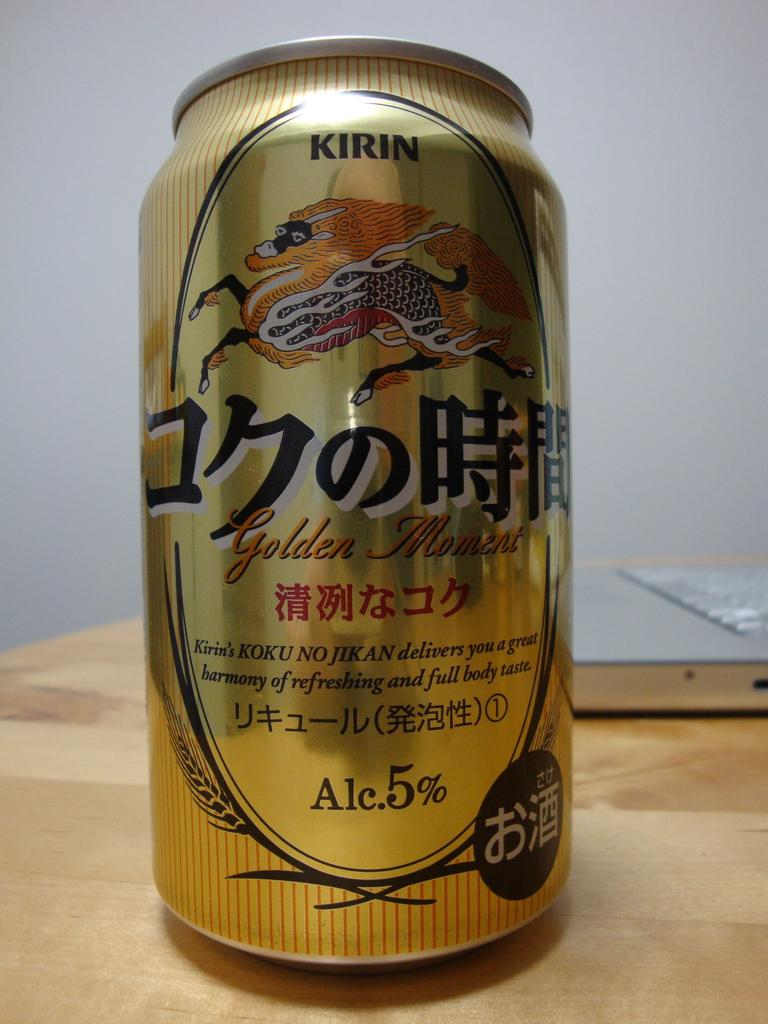<image>
Summarize the visual content of the image. A can of Golden Moment Kirin on a wooden table. 